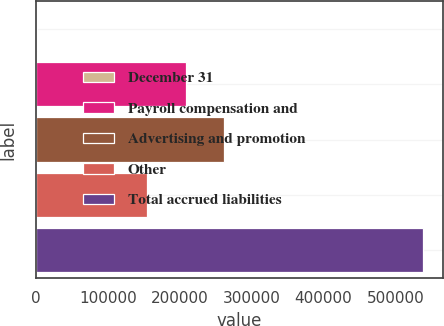<chart> <loc_0><loc_0><loc_500><loc_500><bar_chart><fcel>December 31<fcel>Payroll compensation and<fcel>Advertising and promotion<fcel>Other<fcel>Total accrued liabilities<nl><fcel>2007<fcel>208481<fcel>262179<fcel>154783<fcel>538986<nl></chart> 